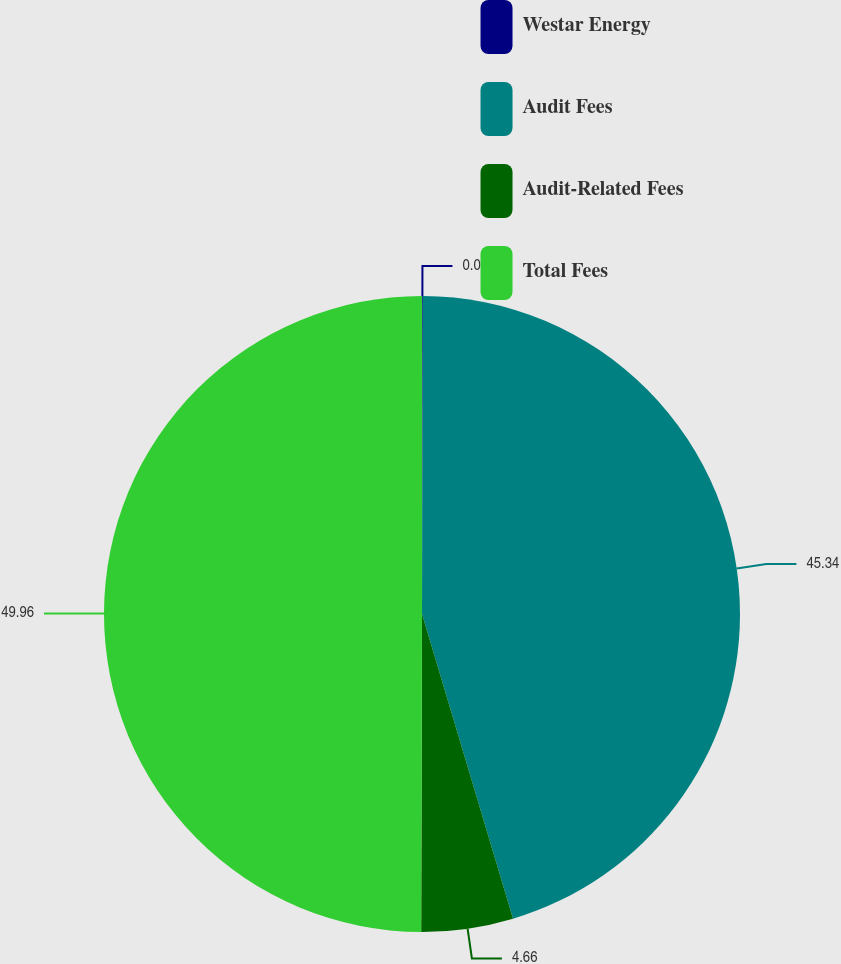Convert chart to OTSL. <chart><loc_0><loc_0><loc_500><loc_500><pie_chart><fcel>Westar Energy<fcel>Audit Fees<fcel>Audit-Related Fees<fcel>Total Fees<nl><fcel>0.04%<fcel>45.34%<fcel>4.66%<fcel>49.96%<nl></chart> 